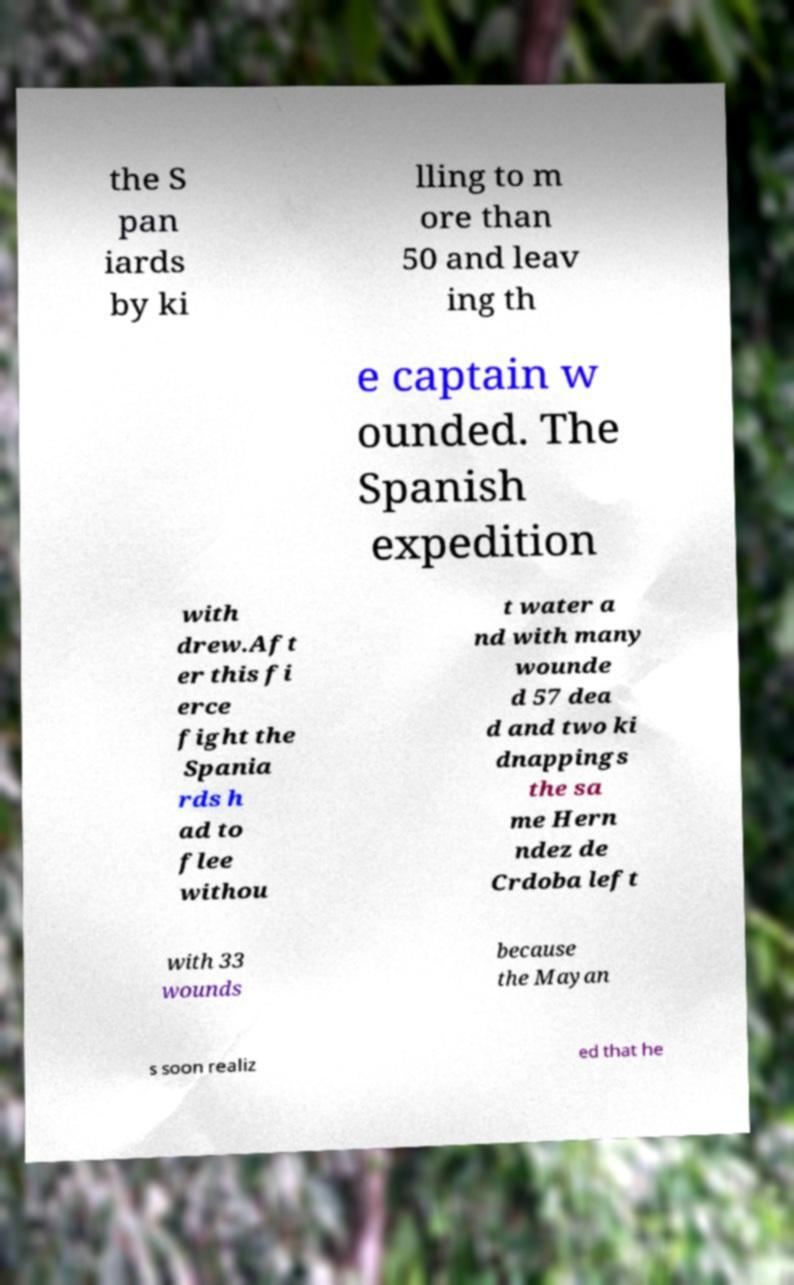There's text embedded in this image that I need extracted. Can you transcribe it verbatim? the S pan iards by ki lling to m ore than 50 and leav ing th e captain w ounded. The Spanish expedition with drew.Aft er this fi erce fight the Spania rds h ad to flee withou t water a nd with many wounde d 57 dea d and two ki dnappings the sa me Hern ndez de Crdoba left with 33 wounds because the Mayan s soon realiz ed that he 